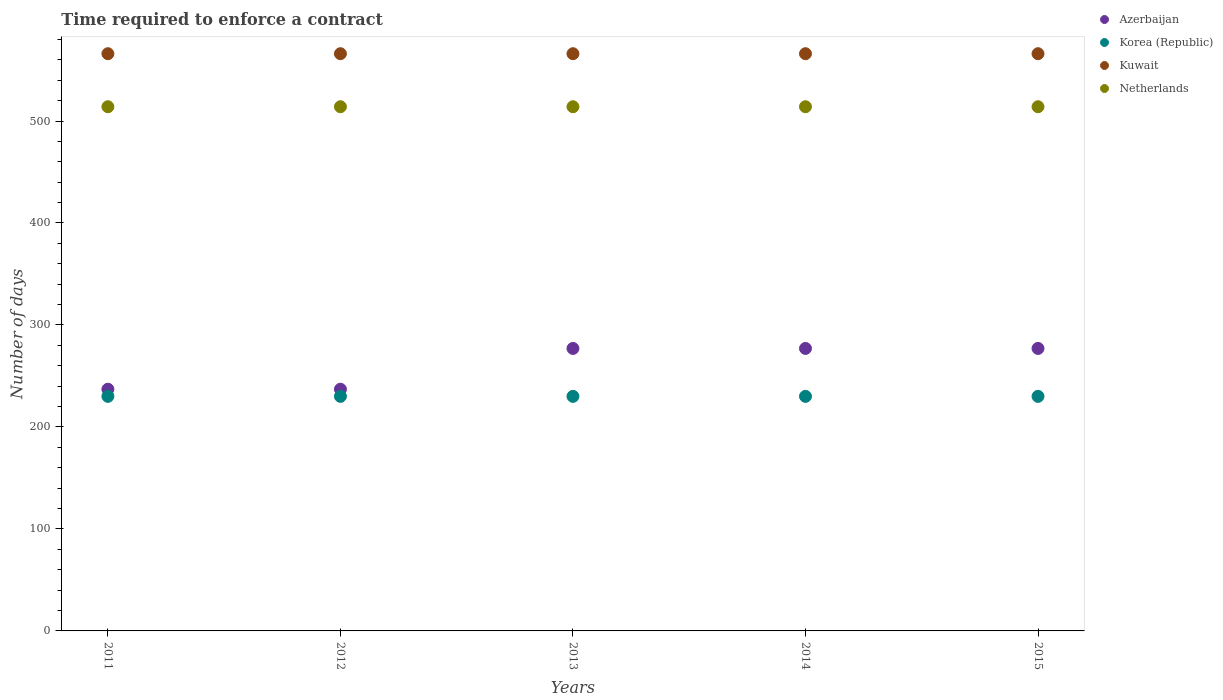Is the number of dotlines equal to the number of legend labels?
Provide a short and direct response. Yes. What is the number of days required to enforce a contract in Kuwait in 2012?
Your answer should be compact. 566. Across all years, what is the maximum number of days required to enforce a contract in Netherlands?
Provide a succinct answer. 514. Across all years, what is the minimum number of days required to enforce a contract in Azerbaijan?
Keep it short and to the point. 237. In which year was the number of days required to enforce a contract in Korea (Republic) maximum?
Your response must be concise. 2011. In which year was the number of days required to enforce a contract in Kuwait minimum?
Your answer should be compact. 2011. What is the total number of days required to enforce a contract in Korea (Republic) in the graph?
Your answer should be very brief. 1150. What is the difference between the number of days required to enforce a contract in Kuwait in 2013 and the number of days required to enforce a contract in Netherlands in 2012?
Offer a terse response. 52. What is the average number of days required to enforce a contract in Azerbaijan per year?
Offer a terse response. 261. In the year 2015, what is the difference between the number of days required to enforce a contract in Netherlands and number of days required to enforce a contract in Korea (Republic)?
Make the answer very short. 284. What is the ratio of the number of days required to enforce a contract in Azerbaijan in 2013 to that in 2015?
Make the answer very short. 1. Is the difference between the number of days required to enforce a contract in Netherlands in 2012 and 2013 greater than the difference between the number of days required to enforce a contract in Korea (Republic) in 2012 and 2013?
Provide a succinct answer. No. What is the difference between the highest and the lowest number of days required to enforce a contract in Azerbaijan?
Offer a very short reply. 40. In how many years, is the number of days required to enforce a contract in Azerbaijan greater than the average number of days required to enforce a contract in Azerbaijan taken over all years?
Keep it short and to the point. 3. Is it the case that in every year, the sum of the number of days required to enforce a contract in Korea (Republic) and number of days required to enforce a contract in Azerbaijan  is greater than the number of days required to enforce a contract in Kuwait?
Keep it short and to the point. No. Is the number of days required to enforce a contract in Kuwait strictly greater than the number of days required to enforce a contract in Azerbaijan over the years?
Give a very brief answer. Yes. Is the number of days required to enforce a contract in Korea (Republic) strictly less than the number of days required to enforce a contract in Kuwait over the years?
Ensure brevity in your answer.  Yes. How many dotlines are there?
Provide a succinct answer. 4. How many years are there in the graph?
Your answer should be very brief. 5. Are the values on the major ticks of Y-axis written in scientific E-notation?
Make the answer very short. No. How many legend labels are there?
Ensure brevity in your answer.  4. What is the title of the graph?
Offer a terse response. Time required to enforce a contract. What is the label or title of the Y-axis?
Make the answer very short. Number of days. What is the Number of days in Azerbaijan in 2011?
Offer a very short reply. 237. What is the Number of days in Korea (Republic) in 2011?
Your response must be concise. 230. What is the Number of days in Kuwait in 2011?
Offer a very short reply. 566. What is the Number of days in Netherlands in 2011?
Your response must be concise. 514. What is the Number of days in Azerbaijan in 2012?
Give a very brief answer. 237. What is the Number of days in Korea (Republic) in 2012?
Make the answer very short. 230. What is the Number of days in Kuwait in 2012?
Keep it short and to the point. 566. What is the Number of days in Netherlands in 2012?
Provide a short and direct response. 514. What is the Number of days of Azerbaijan in 2013?
Give a very brief answer. 277. What is the Number of days of Korea (Republic) in 2013?
Provide a short and direct response. 230. What is the Number of days in Kuwait in 2013?
Offer a terse response. 566. What is the Number of days of Netherlands in 2013?
Your answer should be compact. 514. What is the Number of days in Azerbaijan in 2014?
Your answer should be very brief. 277. What is the Number of days of Korea (Republic) in 2014?
Make the answer very short. 230. What is the Number of days of Kuwait in 2014?
Your response must be concise. 566. What is the Number of days of Netherlands in 2014?
Provide a short and direct response. 514. What is the Number of days in Azerbaijan in 2015?
Offer a very short reply. 277. What is the Number of days of Korea (Republic) in 2015?
Offer a very short reply. 230. What is the Number of days in Kuwait in 2015?
Provide a succinct answer. 566. What is the Number of days in Netherlands in 2015?
Ensure brevity in your answer.  514. Across all years, what is the maximum Number of days of Azerbaijan?
Offer a very short reply. 277. Across all years, what is the maximum Number of days of Korea (Republic)?
Your answer should be very brief. 230. Across all years, what is the maximum Number of days of Kuwait?
Provide a succinct answer. 566. Across all years, what is the maximum Number of days of Netherlands?
Your answer should be compact. 514. Across all years, what is the minimum Number of days in Azerbaijan?
Provide a succinct answer. 237. Across all years, what is the minimum Number of days in Korea (Republic)?
Provide a succinct answer. 230. Across all years, what is the minimum Number of days of Kuwait?
Your answer should be compact. 566. Across all years, what is the minimum Number of days of Netherlands?
Offer a very short reply. 514. What is the total Number of days of Azerbaijan in the graph?
Your answer should be compact. 1305. What is the total Number of days in Korea (Republic) in the graph?
Offer a very short reply. 1150. What is the total Number of days in Kuwait in the graph?
Provide a succinct answer. 2830. What is the total Number of days of Netherlands in the graph?
Give a very brief answer. 2570. What is the difference between the Number of days of Korea (Republic) in 2011 and that in 2012?
Give a very brief answer. 0. What is the difference between the Number of days of Kuwait in 2011 and that in 2012?
Your response must be concise. 0. What is the difference between the Number of days in Netherlands in 2011 and that in 2012?
Your answer should be compact. 0. What is the difference between the Number of days of Azerbaijan in 2011 and that in 2014?
Offer a very short reply. -40. What is the difference between the Number of days in Netherlands in 2011 and that in 2014?
Offer a very short reply. 0. What is the difference between the Number of days in Korea (Republic) in 2011 and that in 2015?
Provide a succinct answer. 0. What is the difference between the Number of days of Kuwait in 2011 and that in 2015?
Your response must be concise. 0. What is the difference between the Number of days of Netherlands in 2011 and that in 2015?
Offer a terse response. 0. What is the difference between the Number of days in Korea (Republic) in 2012 and that in 2013?
Your answer should be compact. 0. What is the difference between the Number of days of Kuwait in 2012 and that in 2013?
Keep it short and to the point. 0. What is the difference between the Number of days of Netherlands in 2012 and that in 2013?
Offer a very short reply. 0. What is the difference between the Number of days of Azerbaijan in 2012 and that in 2014?
Your answer should be very brief. -40. What is the difference between the Number of days in Kuwait in 2012 and that in 2014?
Your answer should be very brief. 0. What is the difference between the Number of days in Netherlands in 2012 and that in 2014?
Your response must be concise. 0. What is the difference between the Number of days of Korea (Republic) in 2012 and that in 2015?
Keep it short and to the point. 0. What is the difference between the Number of days in Kuwait in 2012 and that in 2015?
Keep it short and to the point. 0. What is the difference between the Number of days of Netherlands in 2012 and that in 2015?
Your answer should be compact. 0. What is the difference between the Number of days of Azerbaijan in 2013 and that in 2014?
Provide a short and direct response. 0. What is the difference between the Number of days in Kuwait in 2013 and that in 2014?
Make the answer very short. 0. What is the difference between the Number of days in Kuwait in 2014 and that in 2015?
Keep it short and to the point. 0. What is the difference between the Number of days of Azerbaijan in 2011 and the Number of days of Korea (Republic) in 2012?
Your response must be concise. 7. What is the difference between the Number of days of Azerbaijan in 2011 and the Number of days of Kuwait in 2012?
Give a very brief answer. -329. What is the difference between the Number of days in Azerbaijan in 2011 and the Number of days in Netherlands in 2012?
Keep it short and to the point. -277. What is the difference between the Number of days in Korea (Republic) in 2011 and the Number of days in Kuwait in 2012?
Keep it short and to the point. -336. What is the difference between the Number of days of Korea (Republic) in 2011 and the Number of days of Netherlands in 2012?
Offer a terse response. -284. What is the difference between the Number of days in Azerbaijan in 2011 and the Number of days in Korea (Republic) in 2013?
Offer a terse response. 7. What is the difference between the Number of days in Azerbaijan in 2011 and the Number of days in Kuwait in 2013?
Give a very brief answer. -329. What is the difference between the Number of days in Azerbaijan in 2011 and the Number of days in Netherlands in 2013?
Ensure brevity in your answer.  -277. What is the difference between the Number of days in Korea (Republic) in 2011 and the Number of days in Kuwait in 2013?
Offer a terse response. -336. What is the difference between the Number of days in Korea (Republic) in 2011 and the Number of days in Netherlands in 2013?
Make the answer very short. -284. What is the difference between the Number of days of Kuwait in 2011 and the Number of days of Netherlands in 2013?
Keep it short and to the point. 52. What is the difference between the Number of days of Azerbaijan in 2011 and the Number of days of Kuwait in 2014?
Ensure brevity in your answer.  -329. What is the difference between the Number of days in Azerbaijan in 2011 and the Number of days in Netherlands in 2014?
Make the answer very short. -277. What is the difference between the Number of days in Korea (Republic) in 2011 and the Number of days in Kuwait in 2014?
Your answer should be very brief. -336. What is the difference between the Number of days in Korea (Republic) in 2011 and the Number of days in Netherlands in 2014?
Ensure brevity in your answer.  -284. What is the difference between the Number of days of Azerbaijan in 2011 and the Number of days of Korea (Republic) in 2015?
Give a very brief answer. 7. What is the difference between the Number of days of Azerbaijan in 2011 and the Number of days of Kuwait in 2015?
Offer a terse response. -329. What is the difference between the Number of days in Azerbaijan in 2011 and the Number of days in Netherlands in 2015?
Provide a succinct answer. -277. What is the difference between the Number of days in Korea (Republic) in 2011 and the Number of days in Kuwait in 2015?
Provide a short and direct response. -336. What is the difference between the Number of days of Korea (Republic) in 2011 and the Number of days of Netherlands in 2015?
Offer a terse response. -284. What is the difference between the Number of days in Azerbaijan in 2012 and the Number of days in Korea (Republic) in 2013?
Make the answer very short. 7. What is the difference between the Number of days of Azerbaijan in 2012 and the Number of days of Kuwait in 2013?
Ensure brevity in your answer.  -329. What is the difference between the Number of days of Azerbaijan in 2012 and the Number of days of Netherlands in 2013?
Ensure brevity in your answer.  -277. What is the difference between the Number of days of Korea (Republic) in 2012 and the Number of days of Kuwait in 2013?
Your answer should be very brief. -336. What is the difference between the Number of days of Korea (Republic) in 2012 and the Number of days of Netherlands in 2013?
Make the answer very short. -284. What is the difference between the Number of days of Azerbaijan in 2012 and the Number of days of Korea (Republic) in 2014?
Offer a terse response. 7. What is the difference between the Number of days in Azerbaijan in 2012 and the Number of days in Kuwait in 2014?
Your answer should be compact. -329. What is the difference between the Number of days in Azerbaijan in 2012 and the Number of days in Netherlands in 2014?
Provide a succinct answer. -277. What is the difference between the Number of days in Korea (Republic) in 2012 and the Number of days in Kuwait in 2014?
Provide a short and direct response. -336. What is the difference between the Number of days in Korea (Republic) in 2012 and the Number of days in Netherlands in 2014?
Your answer should be compact. -284. What is the difference between the Number of days in Azerbaijan in 2012 and the Number of days in Korea (Republic) in 2015?
Your response must be concise. 7. What is the difference between the Number of days of Azerbaijan in 2012 and the Number of days of Kuwait in 2015?
Offer a very short reply. -329. What is the difference between the Number of days of Azerbaijan in 2012 and the Number of days of Netherlands in 2015?
Your answer should be compact. -277. What is the difference between the Number of days of Korea (Republic) in 2012 and the Number of days of Kuwait in 2015?
Offer a terse response. -336. What is the difference between the Number of days of Korea (Republic) in 2012 and the Number of days of Netherlands in 2015?
Offer a very short reply. -284. What is the difference between the Number of days in Azerbaijan in 2013 and the Number of days in Kuwait in 2014?
Provide a short and direct response. -289. What is the difference between the Number of days of Azerbaijan in 2013 and the Number of days of Netherlands in 2014?
Offer a very short reply. -237. What is the difference between the Number of days of Korea (Republic) in 2013 and the Number of days of Kuwait in 2014?
Offer a very short reply. -336. What is the difference between the Number of days in Korea (Republic) in 2013 and the Number of days in Netherlands in 2014?
Your answer should be very brief. -284. What is the difference between the Number of days of Azerbaijan in 2013 and the Number of days of Korea (Republic) in 2015?
Give a very brief answer. 47. What is the difference between the Number of days of Azerbaijan in 2013 and the Number of days of Kuwait in 2015?
Offer a terse response. -289. What is the difference between the Number of days in Azerbaijan in 2013 and the Number of days in Netherlands in 2015?
Give a very brief answer. -237. What is the difference between the Number of days of Korea (Republic) in 2013 and the Number of days of Kuwait in 2015?
Ensure brevity in your answer.  -336. What is the difference between the Number of days in Korea (Republic) in 2013 and the Number of days in Netherlands in 2015?
Make the answer very short. -284. What is the difference between the Number of days of Kuwait in 2013 and the Number of days of Netherlands in 2015?
Give a very brief answer. 52. What is the difference between the Number of days of Azerbaijan in 2014 and the Number of days of Korea (Republic) in 2015?
Offer a terse response. 47. What is the difference between the Number of days of Azerbaijan in 2014 and the Number of days of Kuwait in 2015?
Make the answer very short. -289. What is the difference between the Number of days of Azerbaijan in 2014 and the Number of days of Netherlands in 2015?
Your answer should be very brief. -237. What is the difference between the Number of days in Korea (Republic) in 2014 and the Number of days in Kuwait in 2015?
Give a very brief answer. -336. What is the difference between the Number of days in Korea (Republic) in 2014 and the Number of days in Netherlands in 2015?
Provide a short and direct response. -284. What is the average Number of days of Azerbaijan per year?
Keep it short and to the point. 261. What is the average Number of days in Korea (Republic) per year?
Provide a short and direct response. 230. What is the average Number of days in Kuwait per year?
Offer a terse response. 566. What is the average Number of days in Netherlands per year?
Make the answer very short. 514. In the year 2011, what is the difference between the Number of days in Azerbaijan and Number of days in Kuwait?
Ensure brevity in your answer.  -329. In the year 2011, what is the difference between the Number of days of Azerbaijan and Number of days of Netherlands?
Your response must be concise. -277. In the year 2011, what is the difference between the Number of days in Korea (Republic) and Number of days in Kuwait?
Your answer should be very brief. -336. In the year 2011, what is the difference between the Number of days of Korea (Republic) and Number of days of Netherlands?
Provide a succinct answer. -284. In the year 2011, what is the difference between the Number of days in Kuwait and Number of days in Netherlands?
Provide a short and direct response. 52. In the year 2012, what is the difference between the Number of days in Azerbaijan and Number of days in Korea (Republic)?
Provide a succinct answer. 7. In the year 2012, what is the difference between the Number of days of Azerbaijan and Number of days of Kuwait?
Provide a short and direct response. -329. In the year 2012, what is the difference between the Number of days of Azerbaijan and Number of days of Netherlands?
Provide a short and direct response. -277. In the year 2012, what is the difference between the Number of days of Korea (Republic) and Number of days of Kuwait?
Your answer should be very brief. -336. In the year 2012, what is the difference between the Number of days in Korea (Republic) and Number of days in Netherlands?
Provide a succinct answer. -284. In the year 2013, what is the difference between the Number of days of Azerbaijan and Number of days of Korea (Republic)?
Make the answer very short. 47. In the year 2013, what is the difference between the Number of days in Azerbaijan and Number of days in Kuwait?
Ensure brevity in your answer.  -289. In the year 2013, what is the difference between the Number of days in Azerbaijan and Number of days in Netherlands?
Your answer should be very brief. -237. In the year 2013, what is the difference between the Number of days in Korea (Republic) and Number of days in Kuwait?
Offer a terse response. -336. In the year 2013, what is the difference between the Number of days in Korea (Republic) and Number of days in Netherlands?
Offer a terse response. -284. In the year 2014, what is the difference between the Number of days in Azerbaijan and Number of days in Korea (Republic)?
Offer a very short reply. 47. In the year 2014, what is the difference between the Number of days of Azerbaijan and Number of days of Kuwait?
Make the answer very short. -289. In the year 2014, what is the difference between the Number of days in Azerbaijan and Number of days in Netherlands?
Provide a succinct answer. -237. In the year 2014, what is the difference between the Number of days in Korea (Republic) and Number of days in Kuwait?
Give a very brief answer. -336. In the year 2014, what is the difference between the Number of days in Korea (Republic) and Number of days in Netherlands?
Your response must be concise. -284. In the year 2014, what is the difference between the Number of days of Kuwait and Number of days of Netherlands?
Make the answer very short. 52. In the year 2015, what is the difference between the Number of days of Azerbaijan and Number of days of Korea (Republic)?
Provide a short and direct response. 47. In the year 2015, what is the difference between the Number of days in Azerbaijan and Number of days in Kuwait?
Your response must be concise. -289. In the year 2015, what is the difference between the Number of days of Azerbaijan and Number of days of Netherlands?
Provide a succinct answer. -237. In the year 2015, what is the difference between the Number of days of Korea (Republic) and Number of days of Kuwait?
Provide a succinct answer. -336. In the year 2015, what is the difference between the Number of days in Korea (Republic) and Number of days in Netherlands?
Ensure brevity in your answer.  -284. What is the ratio of the Number of days in Netherlands in 2011 to that in 2012?
Give a very brief answer. 1. What is the ratio of the Number of days of Azerbaijan in 2011 to that in 2013?
Your response must be concise. 0.86. What is the ratio of the Number of days in Kuwait in 2011 to that in 2013?
Keep it short and to the point. 1. What is the ratio of the Number of days of Netherlands in 2011 to that in 2013?
Give a very brief answer. 1. What is the ratio of the Number of days in Azerbaijan in 2011 to that in 2014?
Ensure brevity in your answer.  0.86. What is the ratio of the Number of days in Korea (Republic) in 2011 to that in 2014?
Your answer should be compact. 1. What is the ratio of the Number of days in Kuwait in 2011 to that in 2014?
Ensure brevity in your answer.  1. What is the ratio of the Number of days in Azerbaijan in 2011 to that in 2015?
Provide a succinct answer. 0.86. What is the ratio of the Number of days of Kuwait in 2011 to that in 2015?
Offer a terse response. 1. What is the ratio of the Number of days in Azerbaijan in 2012 to that in 2013?
Your answer should be very brief. 0.86. What is the ratio of the Number of days in Korea (Republic) in 2012 to that in 2013?
Offer a very short reply. 1. What is the ratio of the Number of days of Netherlands in 2012 to that in 2013?
Your answer should be compact. 1. What is the ratio of the Number of days in Azerbaijan in 2012 to that in 2014?
Your answer should be compact. 0.86. What is the ratio of the Number of days of Kuwait in 2012 to that in 2014?
Your response must be concise. 1. What is the ratio of the Number of days of Netherlands in 2012 to that in 2014?
Offer a very short reply. 1. What is the ratio of the Number of days of Azerbaijan in 2012 to that in 2015?
Your answer should be compact. 0.86. What is the ratio of the Number of days in Azerbaijan in 2013 to that in 2014?
Offer a terse response. 1. What is the ratio of the Number of days in Korea (Republic) in 2013 to that in 2014?
Keep it short and to the point. 1. What is the ratio of the Number of days of Kuwait in 2013 to that in 2014?
Provide a succinct answer. 1. What is the ratio of the Number of days in Azerbaijan in 2013 to that in 2015?
Offer a very short reply. 1. What is the ratio of the Number of days of Netherlands in 2013 to that in 2015?
Your answer should be compact. 1. What is the ratio of the Number of days of Azerbaijan in 2014 to that in 2015?
Ensure brevity in your answer.  1. What is the ratio of the Number of days in Korea (Republic) in 2014 to that in 2015?
Offer a terse response. 1. What is the ratio of the Number of days of Kuwait in 2014 to that in 2015?
Offer a terse response. 1. What is the ratio of the Number of days of Netherlands in 2014 to that in 2015?
Offer a terse response. 1. What is the difference between the highest and the second highest Number of days in Azerbaijan?
Keep it short and to the point. 0. What is the difference between the highest and the second highest Number of days of Kuwait?
Your answer should be compact. 0. What is the difference between the highest and the lowest Number of days of Azerbaijan?
Your answer should be compact. 40. What is the difference between the highest and the lowest Number of days of Kuwait?
Give a very brief answer. 0. 